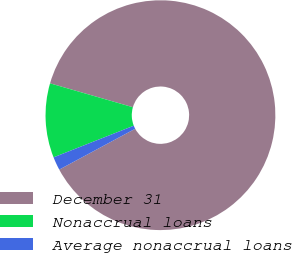<chart> <loc_0><loc_0><loc_500><loc_500><pie_chart><fcel>December 31<fcel>Nonaccrual loans<fcel>Average nonaccrual loans<nl><fcel>87.67%<fcel>10.45%<fcel>1.87%<nl></chart> 